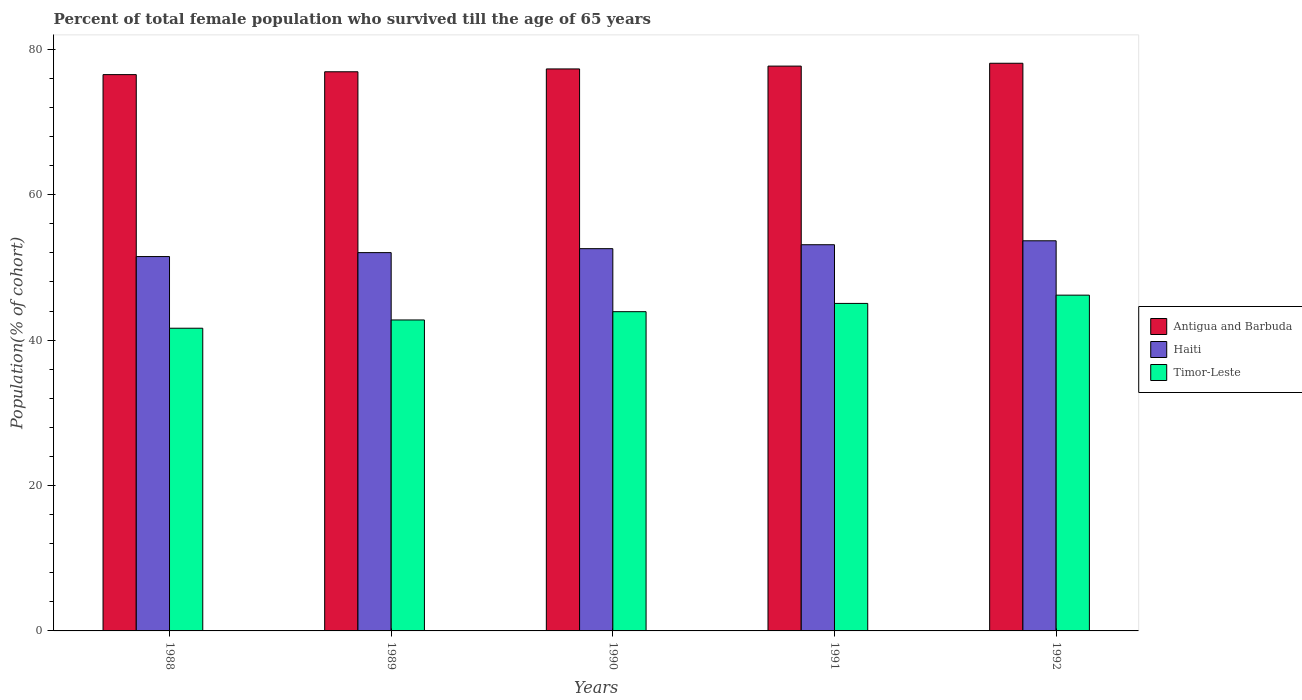How many different coloured bars are there?
Provide a succinct answer. 3. Are the number of bars per tick equal to the number of legend labels?
Your answer should be compact. Yes. Are the number of bars on each tick of the X-axis equal?
Keep it short and to the point. Yes. How many bars are there on the 5th tick from the left?
Your response must be concise. 3. What is the label of the 1st group of bars from the left?
Give a very brief answer. 1988. In how many cases, is the number of bars for a given year not equal to the number of legend labels?
Your response must be concise. 0. What is the percentage of total female population who survived till the age of 65 years in Timor-Leste in 1988?
Provide a short and direct response. 41.64. Across all years, what is the maximum percentage of total female population who survived till the age of 65 years in Timor-Leste?
Your answer should be very brief. 46.19. Across all years, what is the minimum percentage of total female population who survived till the age of 65 years in Antigua and Barbuda?
Your response must be concise. 76.53. What is the total percentage of total female population who survived till the age of 65 years in Antigua and Barbuda in the graph?
Offer a terse response. 386.53. What is the difference between the percentage of total female population who survived till the age of 65 years in Haiti in 1990 and that in 1991?
Your answer should be compact. -0.54. What is the difference between the percentage of total female population who survived till the age of 65 years in Antigua and Barbuda in 1989 and the percentage of total female population who survived till the age of 65 years in Haiti in 1990?
Your answer should be compact. 24.33. What is the average percentage of total female population who survived till the age of 65 years in Antigua and Barbuda per year?
Offer a very short reply. 77.31. In the year 1988, what is the difference between the percentage of total female population who survived till the age of 65 years in Haiti and percentage of total female population who survived till the age of 65 years in Antigua and Barbuda?
Offer a very short reply. -25.03. What is the ratio of the percentage of total female population who survived till the age of 65 years in Timor-Leste in 1991 to that in 1992?
Offer a very short reply. 0.98. Is the difference between the percentage of total female population who survived till the age of 65 years in Haiti in 1989 and 1990 greater than the difference between the percentage of total female population who survived till the age of 65 years in Antigua and Barbuda in 1989 and 1990?
Provide a short and direct response. No. What is the difference between the highest and the second highest percentage of total female population who survived till the age of 65 years in Timor-Leste?
Give a very brief answer. 1.14. What is the difference between the highest and the lowest percentage of total female population who survived till the age of 65 years in Haiti?
Your response must be concise. 2.17. Is the sum of the percentage of total female population who survived till the age of 65 years in Haiti in 1988 and 1992 greater than the maximum percentage of total female population who survived till the age of 65 years in Timor-Leste across all years?
Provide a short and direct response. Yes. What does the 2nd bar from the left in 1990 represents?
Provide a short and direct response. Haiti. What does the 2nd bar from the right in 1988 represents?
Provide a succinct answer. Haiti. Is it the case that in every year, the sum of the percentage of total female population who survived till the age of 65 years in Haiti and percentage of total female population who survived till the age of 65 years in Antigua and Barbuda is greater than the percentage of total female population who survived till the age of 65 years in Timor-Leste?
Ensure brevity in your answer.  Yes. How many bars are there?
Give a very brief answer. 15. Are the values on the major ticks of Y-axis written in scientific E-notation?
Provide a succinct answer. No. What is the title of the graph?
Ensure brevity in your answer.  Percent of total female population who survived till the age of 65 years. Does "Turks and Caicos Islands" appear as one of the legend labels in the graph?
Offer a terse response. No. What is the label or title of the Y-axis?
Make the answer very short. Population(% of cohort). What is the Population(% of cohort) in Antigua and Barbuda in 1988?
Your answer should be very brief. 76.53. What is the Population(% of cohort) of Haiti in 1988?
Your response must be concise. 51.5. What is the Population(% of cohort) in Timor-Leste in 1988?
Your answer should be compact. 41.64. What is the Population(% of cohort) in Antigua and Barbuda in 1989?
Your response must be concise. 76.92. What is the Population(% of cohort) in Haiti in 1989?
Provide a short and direct response. 52.04. What is the Population(% of cohort) in Timor-Leste in 1989?
Your answer should be very brief. 42.78. What is the Population(% of cohort) of Antigua and Barbuda in 1990?
Provide a succinct answer. 77.31. What is the Population(% of cohort) of Haiti in 1990?
Ensure brevity in your answer.  52.58. What is the Population(% of cohort) of Timor-Leste in 1990?
Offer a terse response. 43.91. What is the Population(% of cohort) in Antigua and Barbuda in 1991?
Your response must be concise. 77.7. What is the Population(% of cohort) of Haiti in 1991?
Make the answer very short. 53.12. What is the Population(% of cohort) in Timor-Leste in 1991?
Your answer should be compact. 45.05. What is the Population(% of cohort) in Antigua and Barbuda in 1992?
Keep it short and to the point. 78.09. What is the Population(% of cohort) in Haiti in 1992?
Provide a succinct answer. 53.67. What is the Population(% of cohort) of Timor-Leste in 1992?
Your response must be concise. 46.19. Across all years, what is the maximum Population(% of cohort) of Antigua and Barbuda?
Keep it short and to the point. 78.09. Across all years, what is the maximum Population(% of cohort) in Haiti?
Ensure brevity in your answer.  53.67. Across all years, what is the maximum Population(% of cohort) of Timor-Leste?
Offer a very short reply. 46.19. Across all years, what is the minimum Population(% of cohort) of Antigua and Barbuda?
Offer a terse response. 76.53. Across all years, what is the minimum Population(% of cohort) in Haiti?
Provide a succinct answer. 51.5. Across all years, what is the minimum Population(% of cohort) in Timor-Leste?
Ensure brevity in your answer.  41.64. What is the total Population(% of cohort) in Antigua and Barbuda in the graph?
Offer a terse response. 386.53. What is the total Population(% of cohort) of Haiti in the graph?
Offer a terse response. 262.91. What is the total Population(% of cohort) of Timor-Leste in the graph?
Your answer should be very brief. 219.57. What is the difference between the Population(% of cohort) in Antigua and Barbuda in 1988 and that in 1989?
Keep it short and to the point. -0.39. What is the difference between the Population(% of cohort) of Haiti in 1988 and that in 1989?
Make the answer very short. -0.54. What is the difference between the Population(% of cohort) of Timor-Leste in 1988 and that in 1989?
Provide a succinct answer. -1.14. What is the difference between the Population(% of cohort) in Antigua and Barbuda in 1988 and that in 1990?
Provide a succinct answer. -0.78. What is the difference between the Population(% of cohort) in Haiti in 1988 and that in 1990?
Give a very brief answer. -1.08. What is the difference between the Population(% of cohort) of Timor-Leste in 1988 and that in 1990?
Ensure brevity in your answer.  -2.28. What is the difference between the Population(% of cohort) of Antigua and Barbuda in 1988 and that in 1991?
Offer a terse response. -1.17. What is the difference between the Population(% of cohort) of Haiti in 1988 and that in 1991?
Provide a short and direct response. -1.63. What is the difference between the Population(% of cohort) of Timor-Leste in 1988 and that in 1991?
Your response must be concise. -3.41. What is the difference between the Population(% of cohort) in Antigua and Barbuda in 1988 and that in 1992?
Your answer should be compact. -1.56. What is the difference between the Population(% of cohort) in Haiti in 1988 and that in 1992?
Offer a very short reply. -2.17. What is the difference between the Population(% of cohort) in Timor-Leste in 1988 and that in 1992?
Your response must be concise. -4.55. What is the difference between the Population(% of cohort) of Antigua and Barbuda in 1989 and that in 1990?
Your answer should be very brief. -0.39. What is the difference between the Population(% of cohort) of Haiti in 1989 and that in 1990?
Your answer should be compact. -0.54. What is the difference between the Population(% of cohort) of Timor-Leste in 1989 and that in 1990?
Make the answer very short. -1.14. What is the difference between the Population(% of cohort) of Antigua and Barbuda in 1989 and that in 1991?
Give a very brief answer. -0.78. What is the difference between the Population(% of cohort) in Haiti in 1989 and that in 1991?
Your response must be concise. -1.08. What is the difference between the Population(% of cohort) of Timor-Leste in 1989 and that in 1991?
Offer a very short reply. -2.28. What is the difference between the Population(% of cohort) in Antigua and Barbuda in 1989 and that in 1992?
Your answer should be very brief. -1.17. What is the difference between the Population(% of cohort) in Haiti in 1989 and that in 1992?
Your answer should be very brief. -1.63. What is the difference between the Population(% of cohort) of Timor-Leste in 1989 and that in 1992?
Give a very brief answer. -3.41. What is the difference between the Population(% of cohort) of Antigua and Barbuda in 1990 and that in 1991?
Offer a terse response. -0.39. What is the difference between the Population(% of cohort) in Haiti in 1990 and that in 1991?
Your response must be concise. -0.54. What is the difference between the Population(% of cohort) of Timor-Leste in 1990 and that in 1991?
Offer a terse response. -1.14. What is the difference between the Population(% of cohort) in Antigua and Barbuda in 1990 and that in 1992?
Ensure brevity in your answer.  -0.78. What is the difference between the Population(% of cohort) of Haiti in 1990 and that in 1992?
Offer a terse response. -1.08. What is the difference between the Population(% of cohort) of Timor-Leste in 1990 and that in 1992?
Your answer should be compact. -2.28. What is the difference between the Population(% of cohort) of Antigua and Barbuda in 1991 and that in 1992?
Offer a terse response. -0.39. What is the difference between the Population(% of cohort) in Haiti in 1991 and that in 1992?
Give a very brief answer. -0.54. What is the difference between the Population(% of cohort) in Timor-Leste in 1991 and that in 1992?
Offer a very short reply. -1.14. What is the difference between the Population(% of cohort) of Antigua and Barbuda in 1988 and the Population(% of cohort) of Haiti in 1989?
Keep it short and to the point. 24.49. What is the difference between the Population(% of cohort) in Antigua and Barbuda in 1988 and the Population(% of cohort) in Timor-Leste in 1989?
Provide a succinct answer. 33.75. What is the difference between the Population(% of cohort) in Haiti in 1988 and the Population(% of cohort) in Timor-Leste in 1989?
Keep it short and to the point. 8.72. What is the difference between the Population(% of cohort) in Antigua and Barbuda in 1988 and the Population(% of cohort) in Haiti in 1990?
Your answer should be very brief. 23.94. What is the difference between the Population(% of cohort) in Antigua and Barbuda in 1988 and the Population(% of cohort) in Timor-Leste in 1990?
Provide a succinct answer. 32.61. What is the difference between the Population(% of cohort) of Haiti in 1988 and the Population(% of cohort) of Timor-Leste in 1990?
Make the answer very short. 7.58. What is the difference between the Population(% of cohort) in Antigua and Barbuda in 1988 and the Population(% of cohort) in Haiti in 1991?
Keep it short and to the point. 23.4. What is the difference between the Population(% of cohort) in Antigua and Barbuda in 1988 and the Population(% of cohort) in Timor-Leste in 1991?
Offer a terse response. 31.47. What is the difference between the Population(% of cohort) in Haiti in 1988 and the Population(% of cohort) in Timor-Leste in 1991?
Keep it short and to the point. 6.45. What is the difference between the Population(% of cohort) in Antigua and Barbuda in 1988 and the Population(% of cohort) in Haiti in 1992?
Give a very brief answer. 22.86. What is the difference between the Population(% of cohort) of Antigua and Barbuda in 1988 and the Population(% of cohort) of Timor-Leste in 1992?
Keep it short and to the point. 30.34. What is the difference between the Population(% of cohort) of Haiti in 1988 and the Population(% of cohort) of Timor-Leste in 1992?
Give a very brief answer. 5.31. What is the difference between the Population(% of cohort) of Antigua and Barbuda in 1989 and the Population(% of cohort) of Haiti in 1990?
Your answer should be very brief. 24.33. What is the difference between the Population(% of cohort) of Antigua and Barbuda in 1989 and the Population(% of cohort) of Timor-Leste in 1990?
Give a very brief answer. 33. What is the difference between the Population(% of cohort) of Haiti in 1989 and the Population(% of cohort) of Timor-Leste in 1990?
Offer a very short reply. 8.13. What is the difference between the Population(% of cohort) of Antigua and Barbuda in 1989 and the Population(% of cohort) of Haiti in 1991?
Make the answer very short. 23.79. What is the difference between the Population(% of cohort) in Antigua and Barbuda in 1989 and the Population(% of cohort) in Timor-Leste in 1991?
Your answer should be very brief. 31.86. What is the difference between the Population(% of cohort) in Haiti in 1989 and the Population(% of cohort) in Timor-Leste in 1991?
Your answer should be very brief. 6.99. What is the difference between the Population(% of cohort) in Antigua and Barbuda in 1989 and the Population(% of cohort) in Haiti in 1992?
Provide a succinct answer. 23.25. What is the difference between the Population(% of cohort) in Antigua and Barbuda in 1989 and the Population(% of cohort) in Timor-Leste in 1992?
Provide a succinct answer. 30.73. What is the difference between the Population(% of cohort) of Haiti in 1989 and the Population(% of cohort) of Timor-Leste in 1992?
Offer a very short reply. 5.85. What is the difference between the Population(% of cohort) in Antigua and Barbuda in 1990 and the Population(% of cohort) in Haiti in 1991?
Provide a short and direct response. 24.18. What is the difference between the Population(% of cohort) of Antigua and Barbuda in 1990 and the Population(% of cohort) of Timor-Leste in 1991?
Offer a very short reply. 32.25. What is the difference between the Population(% of cohort) in Haiti in 1990 and the Population(% of cohort) in Timor-Leste in 1991?
Your response must be concise. 7.53. What is the difference between the Population(% of cohort) in Antigua and Barbuda in 1990 and the Population(% of cohort) in Haiti in 1992?
Offer a terse response. 23.64. What is the difference between the Population(% of cohort) in Antigua and Barbuda in 1990 and the Population(% of cohort) in Timor-Leste in 1992?
Provide a short and direct response. 31.12. What is the difference between the Population(% of cohort) in Haiti in 1990 and the Population(% of cohort) in Timor-Leste in 1992?
Ensure brevity in your answer.  6.39. What is the difference between the Population(% of cohort) of Antigua and Barbuda in 1991 and the Population(% of cohort) of Haiti in 1992?
Provide a succinct answer. 24.03. What is the difference between the Population(% of cohort) in Antigua and Barbuda in 1991 and the Population(% of cohort) in Timor-Leste in 1992?
Give a very brief answer. 31.51. What is the difference between the Population(% of cohort) in Haiti in 1991 and the Population(% of cohort) in Timor-Leste in 1992?
Make the answer very short. 6.93. What is the average Population(% of cohort) of Antigua and Barbuda per year?
Keep it short and to the point. 77.31. What is the average Population(% of cohort) in Haiti per year?
Keep it short and to the point. 52.58. What is the average Population(% of cohort) in Timor-Leste per year?
Keep it short and to the point. 43.91. In the year 1988, what is the difference between the Population(% of cohort) of Antigua and Barbuda and Population(% of cohort) of Haiti?
Your response must be concise. 25.03. In the year 1988, what is the difference between the Population(% of cohort) of Antigua and Barbuda and Population(% of cohort) of Timor-Leste?
Give a very brief answer. 34.89. In the year 1988, what is the difference between the Population(% of cohort) of Haiti and Population(% of cohort) of Timor-Leste?
Your answer should be compact. 9.86. In the year 1989, what is the difference between the Population(% of cohort) of Antigua and Barbuda and Population(% of cohort) of Haiti?
Make the answer very short. 24.88. In the year 1989, what is the difference between the Population(% of cohort) of Antigua and Barbuda and Population(% of cohort) of Timor-Leste?
Offer a very short reply. 34.14. In the year 1989, what is the difference between the Population(% of cohort) of Haiti and Population(% of cohort) of Timor-Leste?
Make the answer very short. 9.26. In the year 1990, what is the difference between the Population(% of cohort) of Antigua and Barbuda and Population(% of cohort) of Haiti?
Give a very brief answer. 24.72. In the year 1990, what is the difference between the Population(% of cohort) in Antigua and Barbuda and Population(% of cohort) in Timor-Leste?
Ensure brevity in your answer.  33.39. In the year 1990, what is the difference between the Population(% of cohort) of Haiti and Population(% of cohort) of Timor-Leste?
Make the answer very short. 8.67. In the year 1991, what is the difference between the Population(% of cohort) of Antigua and Barbuda and Population(% of cohort) of Haiti?
Provide a succinct answer. 24.57. In the year 1991, what is the difference between the Population(% of cohort) in Antigua and Barbuda and Population(% of cohort) in Timor-Leste?
Your response must be concise. 32.64. In the year 1991, what is the difference between the Population(% of cohort) in Haiti and Population(% of cohort) in Timor-Leste?
Offer a very short reply. 8.07. In the year 1992, what is the difference between the Population(% of cohort) of Antigua and Barbuda and Population(% of cohort) of Haiti?
Provide a short and direct response. 24.42. In the year 1992, what is the difference between the Population(% of cohort) of Antigua and Barbuda and Population(% of cohort) of Timor-Leste?
Your answer should be very brief. 31.9. In the year 1992, what is the difference between the Population(% of cohort) of Haiti and Population(% of cohort) of Timor-Leste?
Ensure brevity in your answer.  7.48. What is the ratio of the Population(% of cohort) of Timor-Leste in 1988 to that in 1989?
Offer a terse response. 0.97. What is the ratio of the Population(% of cohort) in Haiti in 1988 to that in 1990?
Offer a terse response. 0.98. What is the ratio of the Population(% of cohort) of Timor-Leste in 1988 to that in 1990?
Offer a very short reply. 0.95. What is the ratio of the Population(% of cohort) of Antigua and Barbuda in 1988 to that in 1991?
Offer a very short reply. 0.98. What is the ratio of the Population(% of cohort) in Haiti in 1988 to that in 1991?
Give a very brief answer. 0.97. What is the ratio of the Population(% of cohort) of Timor-Leste in 1988 to that in 1991?
Offer a terse response. 0.92. What is the ratio of the Population(% of cohort) of Haiti in 1988 to that in 1992?
Your answer should be compact. 0.96. What is the ratio of the Population(% of cohort) of Timor-Leste in 1988 to that in 1992?
Your response must be concise. 0.9. What is the ratio of the Population(% of cohort) in Haiti in 1989 to that in 1990?
Your response must be concise. 0.99. What is the ratio of the Population(% of cohort) of Timor-Leste in 1989 to that in 1990?
Provide a short and direct response. 0.97. What is the ratio of the Population(% of cohort) of Haiti in 1989 to that in 1991?
Your response must be concise. 0.98. What is the ratio of the Population(% of cohort) in Timor-Leste in 1989 to that in 1991?
Make the answer very short. 0.95. What is the ratio of the Population(% of cohort) in Haiti in 1989 to that in 1992?
Make the answer very short. 0.97. What is the ratio of the Population(% of cohort) of Timor-Leste in 1989 to that in 1992?
Your answer should be compact. 0.93. What is the ratio of the Population(% of cohort) in Timor-Leste in 1990 to that in 1991?
Give a very brief answer. 0.97. What is the ratio of the Population(% of cohort) of Haiti in 1990 to that in 1992?
Ensure brevity in your answer.  0.98. What is the ratio of the Population(% of cohort) in Timor-Leste in 1990 to that in 1992?
Give a very brief answer. 0.95. What is the ratio of the Population(% of cohort) in Haiti in 1991 to that in 1992?
Provide a short and direct response. 0.99. What is the ratio of the Population(% of cohort) of Timor-Leste in 1991 to that in 1992?
Ensure brevity in your answer.  0.98. What is the difference between the highest and the second highest Population(% of cohort) of Antigua and Barbuda?
Keep it short and to the point. 0.39. What is the difference between the highest and the second highest Population(% of cohort) of Haiti?
Give a very brief answer. 0.54. What is the difference between the highest and the second highest Population(% of cohort) of Timor-Leste?
Your answer should be compact. 1.14. What is the difference between the highest and the lowest Population(% of cohort) in Antigua and Barbuda?
Offer a terse response. 1.56. What is the difference between the highest and the lowest Population(% of cohort) of Haiti?
Offer a terse response. 2.17. What is the difference between the highest and the lowest Population(% of cohort) in Timor-Leste?
Make the answer very short. 4.55. 